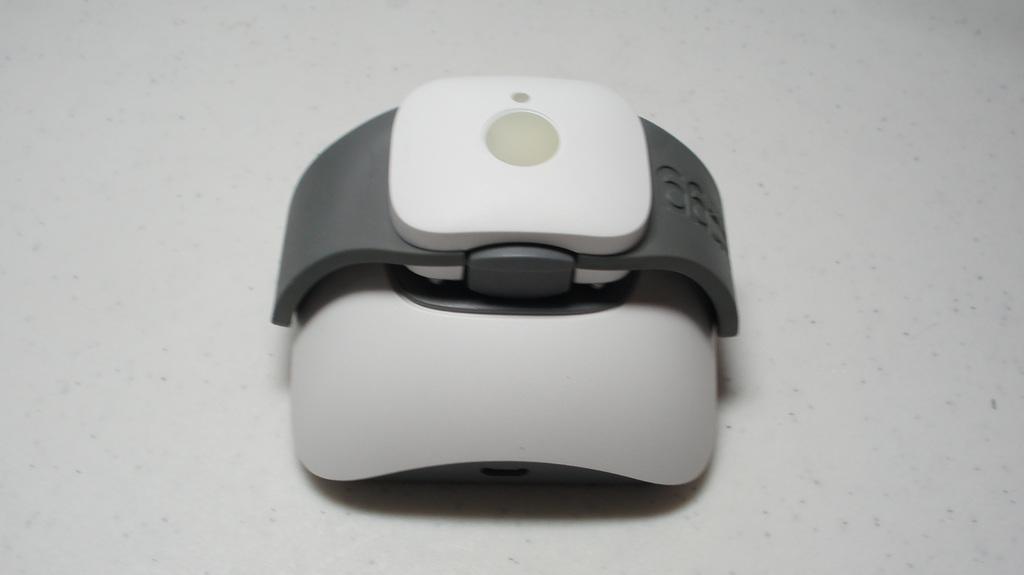Describe this image in one or two sentences. In this picture we can see an electronic gadget. 